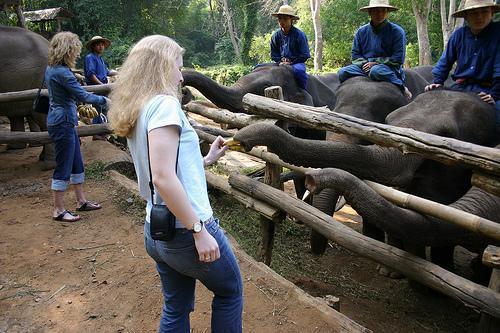How many different kinds of animals are in the photo?
Give a very brief answer. 1. How many people are riding elephants?
Give a very brief answer. 3. How many people are on top of elephants?
Give a very brief answer. 3. 